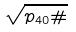<formula> <loc_0><loc_0><loc_500><loc_500>\sqrt { p _ { 4 0 } \# }</formula> 